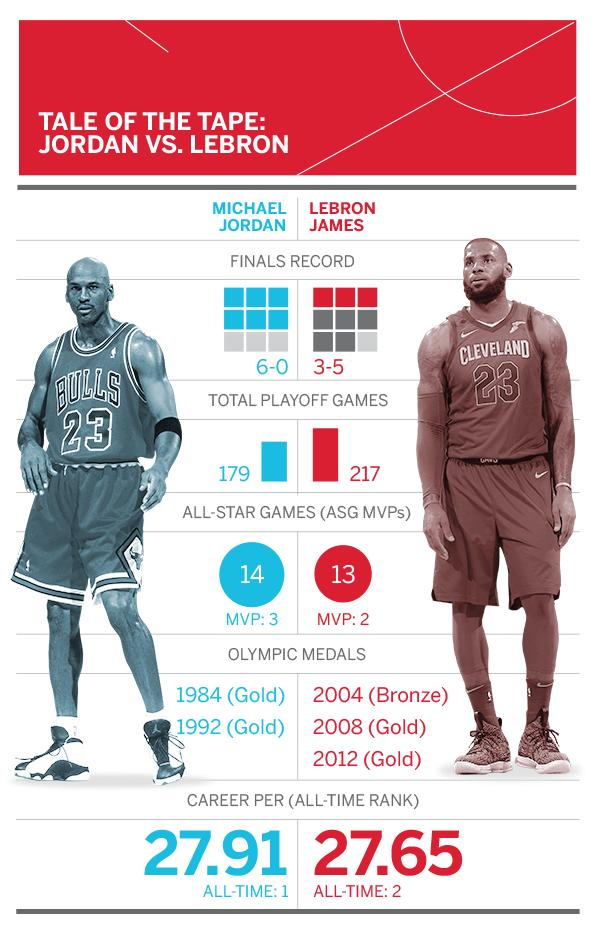Highlight a few significant elements in this photo. It is written on the T-shirt of LeBron James that the number 23 is written. Michael Jordan won gold medals in the Olympics in both 1984 and 1992. I declare that Lebron James is the person who had a beard. In the summer of 2008 and 2012, LeBron James won gold medals in the Olympic Games. It is clear from the information provided that the person wearing a Nike branded t-shirt is none other than the renowned basketball player, LeBron James. 